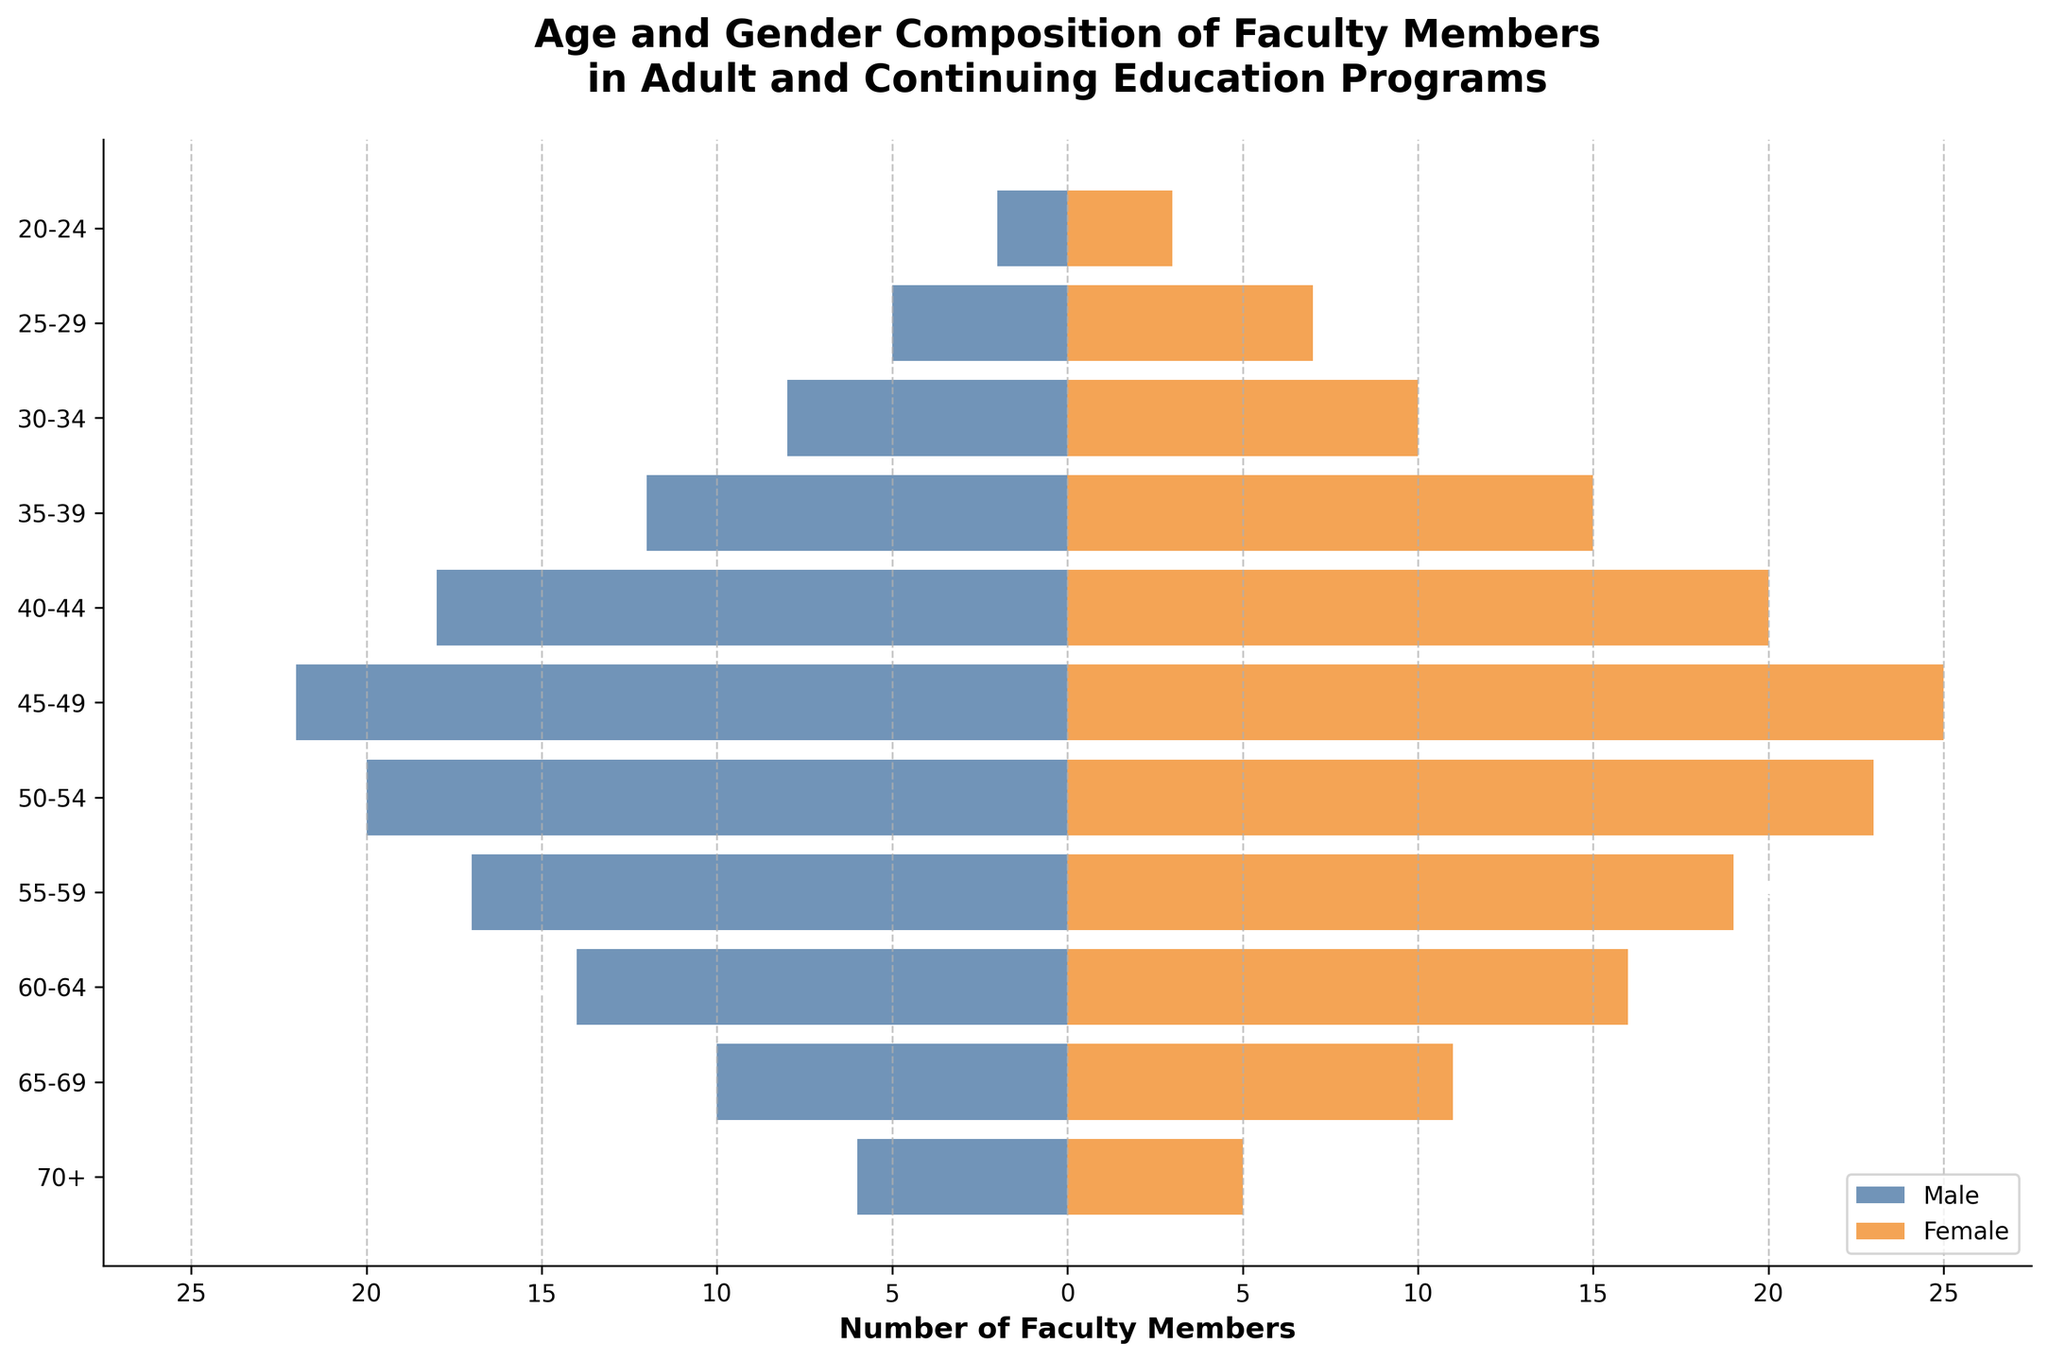What is the title of the figure? The title is displayed at the top of the figure. It indicates that the chart is about the age and gender composition of faculty members in adult and continuing education programs.
Answer: Age and Gender Composition of Faculty Members in Adult and Continuing Education Programs Which age group has the highest number of female faculty members? By looking at the lengths of the orange bars (which represent females), the age group 45-49 has the longest bar.
Answer: 45-49 In which age group do male faculty members outnumber female faculty members the most? By comparing the lengths of the blue (males) and orange (females) bars for each age group, the age group 45-49 shows the most significant difference favoring males.
Answer: 45-49 What is the total number of faculty members in the 40-44 age group? Sum the number of male and female faculty members in the 40-44 age group: 18 (males) + 20 (females) = 38.
Answer: 38 How many more male faculty members are there in the 60-64 age group compared to the 65-69 age group? Subtract the number of male faculty members in the 65-69 age group from the 60-64 age group: 14 (60-64 males) - 10 (65-69 males) = 4.
Answer: 4 Are there more male or female faculty members overall in the given data? Sum the male and female faculty members across all age groups and compare: Total males = 2+5+8+12+18+22+20+17+14+10+6 = 134, Total females = 3+7+10+15+20+25+23+19+16+11+5 = 154. Females outnumber males.
Answer: Females What is the average number of male and female faculty members in the 50-59 age range? Add the number of male and female members in the 50-54 and 55-59 age groups and divide by 2: (20+17)/2 = 18.5 (males), (23+19)/2 = 21 (females).
Answer: 18.5 (males), 21 (females) Which age group has the smallest combined total of male and female faculty members? By summing the male and female faculty members for each age group and comparing, the 20-24 age group has the smallest total: 2 (males) + 3 (females) = 5.
Answer: 20-24 Does any age group have an equal number of male and female faculty members? By comparing the male and female numbers across each age group, there is no age group with equal numbers of males and females.
Answer: No What are the colors used to represent male and female faculty members in the figure? The figure uses blue for males and orange for females, identifiable by the legend at the bottom right corner of the chart.
Answer: Blue (males), Orange (females) 